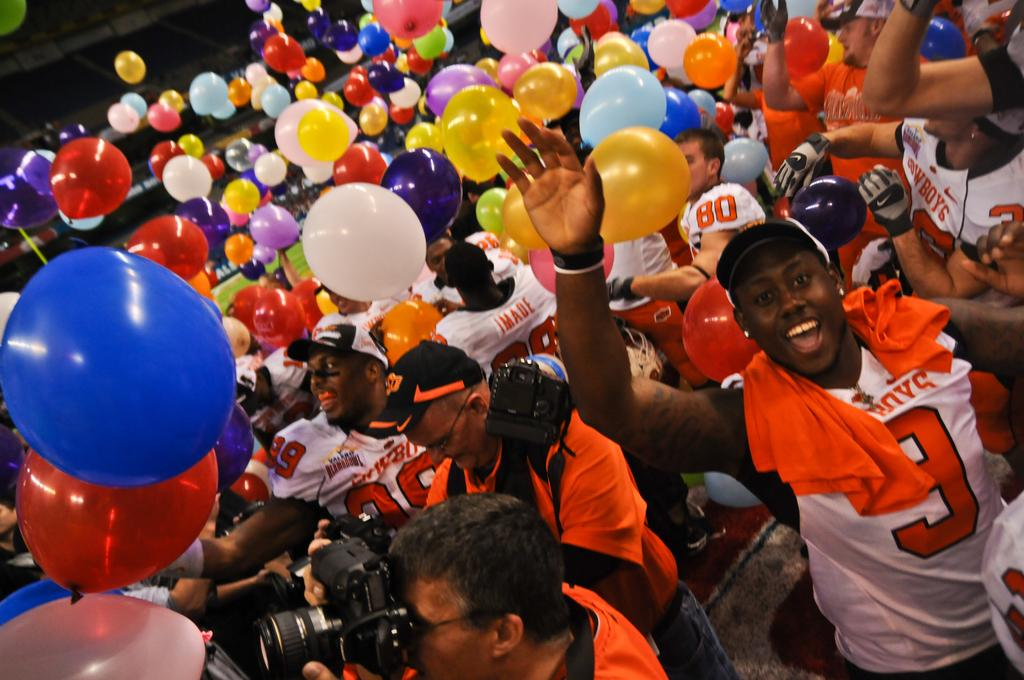What can be seen in the image? There are persons standing in the image. What are the persons wearing? The persons are wearing white and orange jerseys. Are there any other objects or elements in the image? Yes, there are different colored balloons in the image. What type of art is being discussed by the committee in the image? There is no committee or discussion about art present in the image; it features persons standing and wearing jerseys, along with different colored balloons. Can you see any blades in the image? There are no blades visible in the image. 